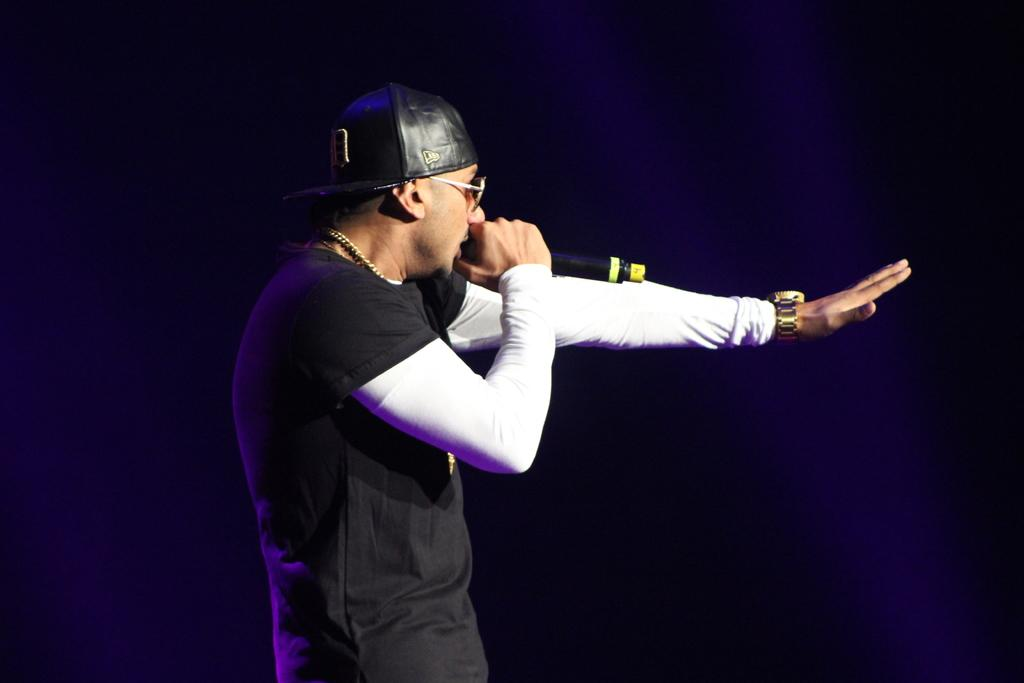What is the main subject of the image? There is a person in the image. What is the person wearing on their upper body? The person is wearing a black T-shirt. What type of headwear is the person wearing? The person is wearing a cap. What type of eyewear is the person wearing? The person is wearing glasses. What type of accessory is the person wearing on their wrist? The person is wearing a watch. What is the person holding in their hands? The person is holding a mic in their hands. How would you describe the lighting in the image? The background of the image is dark. What type of soda is the person drinking in the image? There is no soda present in the image; the person is holding a mic in their hands. 